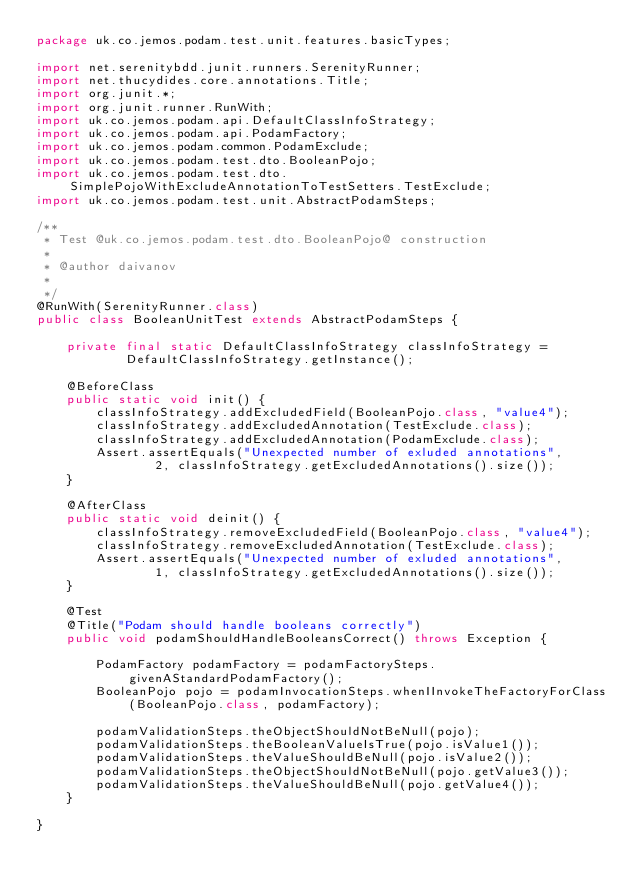<code> <loc_0><loc_0><loc_500><loc_500><_Java_>package uk.co.jemos.podam.test.unit.features.basicTypes;

import net.serenitybdd.junit.runners.SerenityRunner;
import net.thucydides.core.annotations.Title;
import org.junit.*;
import org.junit.runner.RunWith;
import uk.co.jemos.podam.api.DefaultClassInfoStrategy;
import uk.co.jemos.podam.api.PodamFactory;
import uk.co.jemos.podam.common.PodamExclude;
import uk.co.jemos.podam.test.dto.BooleanPojo;
import uk.co.jemos.podam.test.dto.SimplePojoWithExcludeAnnotationToTestSetters.TestExclude;
import uk.co.jemos.podam.test.unit.AbstractPodamSteps;

/**
 * Test @uk.co.jemos.podam.test.dto.BooleanPojo@ construction
 *
 * @author daivanov
 *
 */
@RunWith(SerenityRunner.class)
public class BooleanUnitTest extends AbstractPodamSteps {

	private final static DefaultClassInfoStrategy classInfoStrategy =
			DefaultClassInfoStrategy.getInstance();

	@BeforeClass
	public static void init() {
		classInfoStrategy.addExcludedField(BooleanPojo.class, "value4");
		classInfoStrategy.addExcludedAnnotation(TestExclude.class);
		classInfoStrategy.addExcludedAnnotation(PodamExclude.class);
		Assert.assertEquals("Unexpected number of exluded annotations",
				2, classInfoStrategy.getExcludedAnnotations().size());
	}

	@AfterClass
	public static void deinit() {
		classInfoStrategy.removeExcludedField(BooleanPojo.class, "value4");
		classInfoStrategy.removeExcludedAnnotation(TestExclude.class);
		Assert.assertEquals("Unexpected number of exluded annotations",
				1, classInfoStrategy.getExcludedAnnotations().size());
	}

	@Test
	@Title("Podam should handle booleans correctly")
	public void podamShouldHandleBooleansCorrect() throws Exception {

		PodamFactory podamFactory = podamFactorySteps.givenAStandardPodamFactory();
		BooleanPojo pojo = podamInvocationSteps.whenIInvokeTheFactoryForClass(BooleanPojo.class, podamFactory);

		podamValidationSteps.theObjectShouldNotBeNull(pojo);
		podamValidationSteps.theBooleanValueIsTrue(pojo.isValue1());
		podamValidationSteps.theValueShouldBeNull(pojo.isValue2());
		podamValidationSteps.theObjectShouldNotBeNull(pojo.getValue3());
		podamValidationSteps.theValueShouldBeNull(pojo.getValue4());
	}

}
</code> 